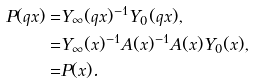Convert formula to latex. <formula><loc_0><loc_0><loc_500><loc_500>P ( q x ) = & Y _ { \infty } ( q x ) ^ { - 1 } Y _ { 0 } ( q x ) , \\ = & Y _ { \infty } ( x ) ^ { - 1 } A ( x ) ^ { - 1 } A ( x ) Y _ { 0 } ( x ) , \\ = & P ( x ) .</formula> 